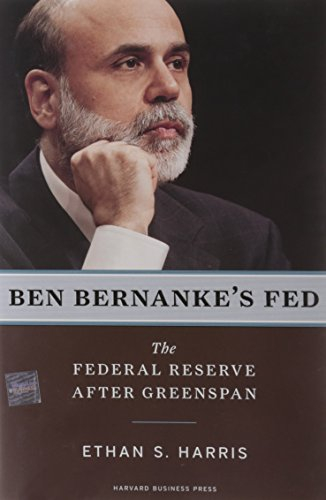What significant events during Bernanke's tenure might be covered in this book? Key events likely covered include the response to the 2008 financial crisis, the implementation of unconventional monetary policies like quantitative easing, and navigating the economy through the recession that followed. 